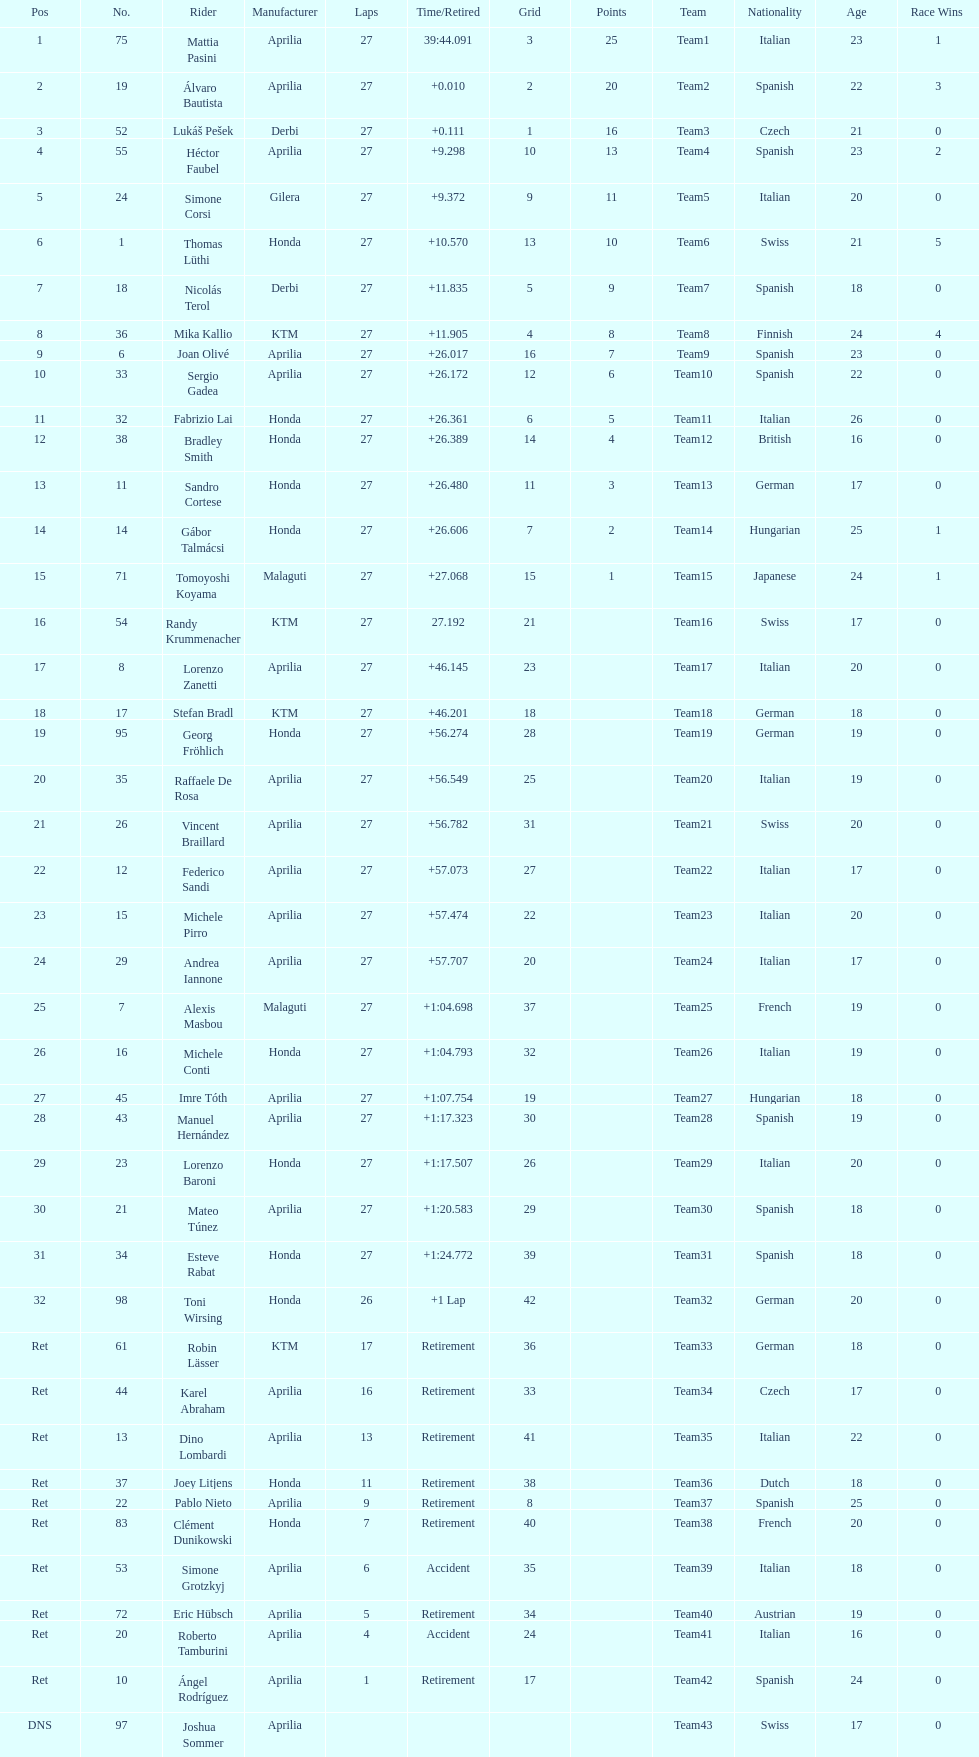Which rider came in first with 25 points? Mattia Pasini. 